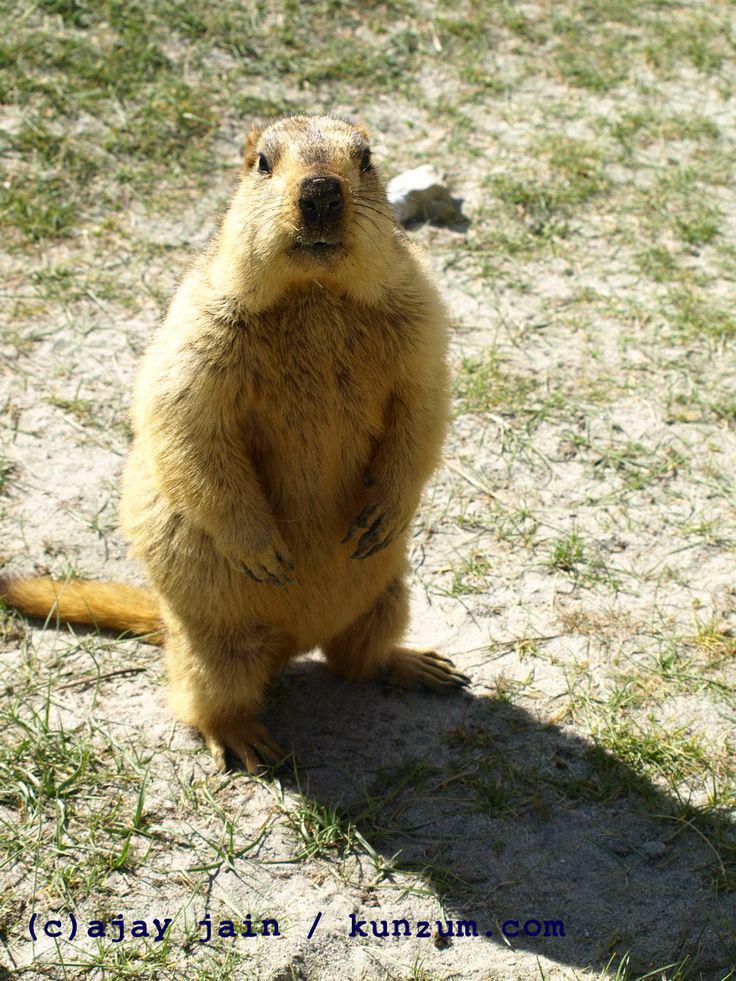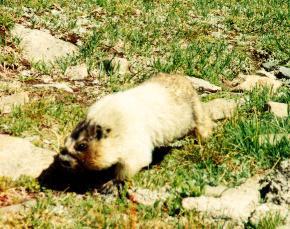The first image is the image on the left, the second image is the image on the right. Given the left and right images, does the statement "There is exactly two rodents." hold true? Answer yes or no. Yes. The first image is the image on the left, the second image is the image on the right. For the images shown, is this caption "There are two rodents out in the open." true? Answer yes or no. Yes. 